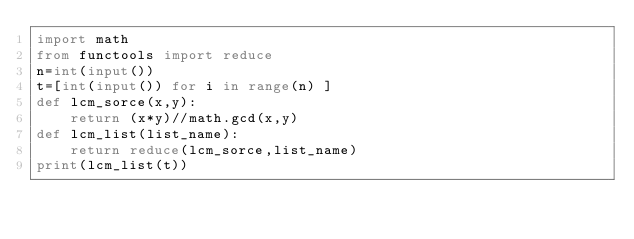<code> <loc_0><loc_0><loc_500><loc_500><_Python_>import math
from functools import reduce
n=int(input())
t=[int(input()) for i in range(n) ]
def lcm_sorce(x,y):
    return (x*y)//math.gcd(x,y)
def lcm_list(list_name):
    return reduce(lcm_sorce,list_name)
print(lcm_list(t))</code> 